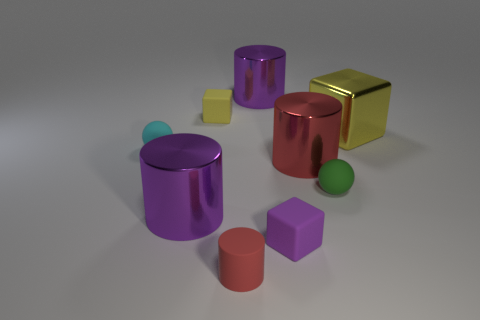There is another rubber block that is the same size as the purple block; what is its color?
Provide a short and direct response. Yellow. Does the tiny cylinder have the same color as the rubber sphere left of the green object?
Provide a short and direct response. No. The tiny matte cylinder has what color?
Provide a short and direct response. Red. There is a purple thing on the left side of the rubber cylinder; what is its material?
Give a very brief answer. Metal. The purple thing that is the same shape as the yellow matte thing is what size?
Ensure brevity in your answer.  Small. Are there fewer small yellow rubber things on the right side of the large yellow metal object than small cyan matte balls?
Your answer should be very brief. Yes. Are there any small blocks?
Ensure brevity in your answer.  Yes. There is another big thing that is the same shape as the yellow rubber thing; what color is it?
Ensure brevity in your answer.  Yellow. There is a ball that is in front of the cyan matte object; does it have the same color as the big metal block?
Offer a terse response. No. Do the purple rubber block and the cyan rubber ball have the same size?
Provide a short and direct response. Yes. 